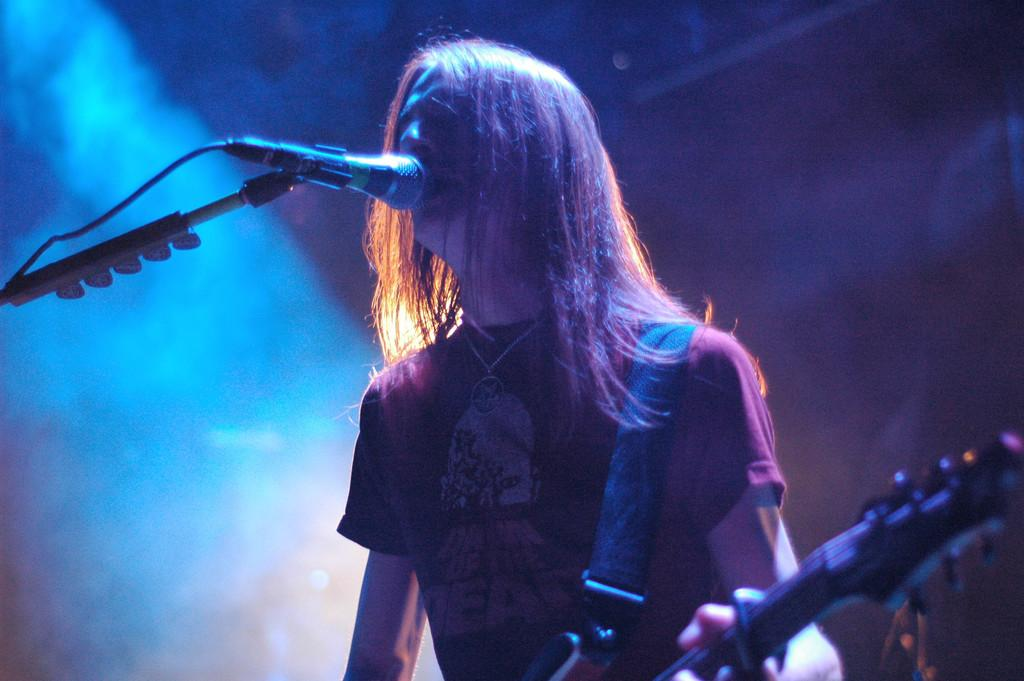Who is the main subject in the image? There is a man in the image. What is the man doing in the image? The man is standing and singing. What object is the man holding in the image? The man is holding a guitar. What device is in front of the man in the image? There is a microphone in front of the man. What type of gun is the governor holding in the image? There is no governor or gun present in the image. The image features a man holding a guitar and singing with a microphone in front of him. 